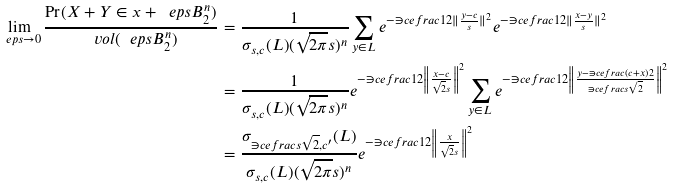Convert formula to latex. <formula><loc_0><loc_0><loc_500><loc_500>\lim _ { \ e p s \rightarrow 0 } \frac { \Pr ( X + Y \in x + \ e p s B _ { 2 } ^ { n } ) } { \ v o l ( \ e p s B _ { 2 } ^ { n } ) } & = \frac { 1 } { \sigma _ { s , c } ( L ) ( \sqrt { 2 \pi } s ) ^ { n } } \sum _ { y \in L } e ^ { - \ni c e f r a c { 1 } { 2 } \| \frac { y - c } { s } \| ^ { 2 } } e ^ { - \ni c e f r a c { 1 } { 2 } \| \frac { x - y } { s } \| ^ { 2 } } \\ & = \frac { 1 } { \sigma _ { s , c } ( L ) ( \sqrt { 2 \pi } s ) ^ { n } } e ^ { - \ni c e f r a c { 1 } { 2 } \left \| \frac { x - c } { \sqrt { 2 } s } \right \| ^ { 2 } } \sum _ { y \in L } e ^ { - \ni c e f r a c { 1 } { 2 } \left \| \frac { y - \ni c e f r a c { ( c + x ) } { 2 } } { \ni c e f r a c { s } { \sqrt { 2 } } } \right \| ^ { 2 } } \\ & = \frac { \sigma _ { \ni c e f r a c { s } { \sqrt { 2 } } , c ^ { \prime } } ( L ) } { \sigma _ { s , c } ( L ) ( \sqrt { 2 \pi } s ) ^ { n } } e ^ { - \ni c e f r a c { 1 } { 2 } \left \| \frac { x } { \sqrt { 2 } s } \right \| ^ { 2 } }</formula> 